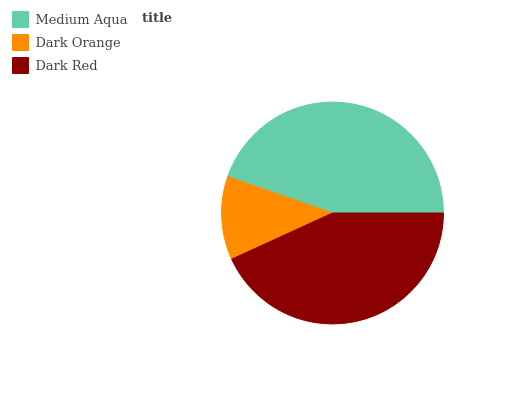Is Dark Orange the minimum?
Answer yes or no. Yes. Is Medium Aqua the maximum?
Answer yes or no. Yes. Is Dark Red the minimum?
Answer yes or no. No. Is Dark Red the maximum?
Answer yes or no. No. Is Dark Red greater than Dark Orange?
Answer yes or no. Yes. Is Dark Orange less than Dark Red?
Answer yes or no. Yes. Is Dark Orange greater than Dark Red?
Answer yes or no. No. Is Dark Red less than Dark Orange?
Answer yes or no. No. Is Dark Red the high median?
Answer yes or no. Yes. Is Dark Red the low median?
Answer yes or no. Yes. Is Dark Orange the high median?
Answer yes or no. No. Is Dark Orange the low median?
Answer yes or no. No. 